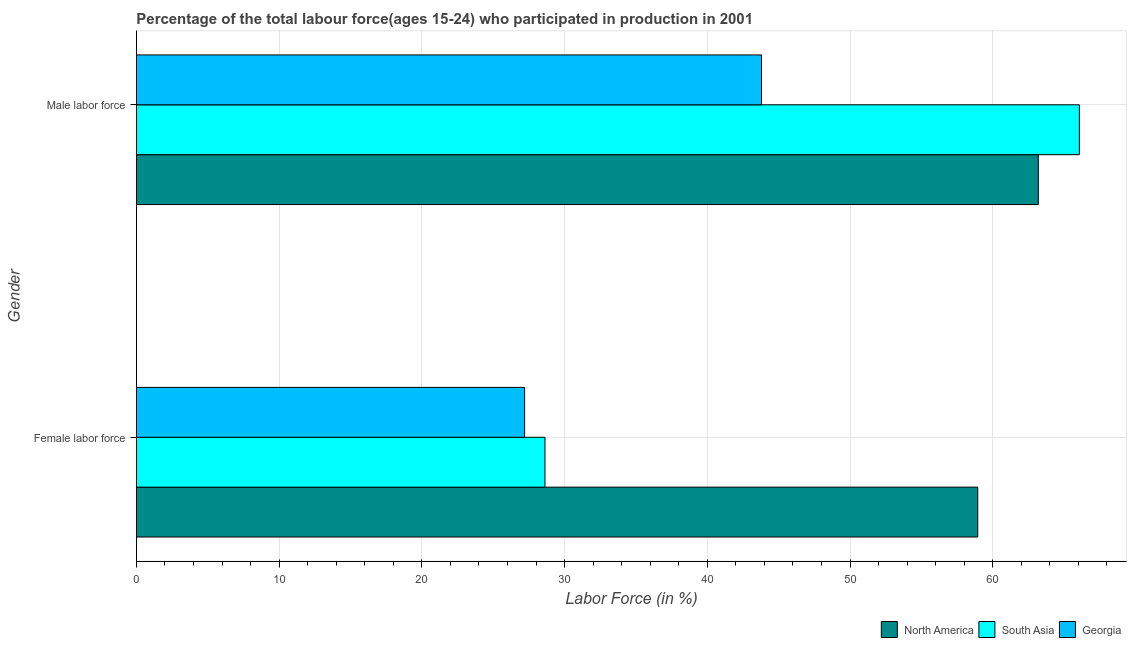How many different coloured bars are there?
Your response must be concise. 3. How many groups of bars are there?
Offer a terse response. 2. How many bars are there on the 2nd tick from the bottom?
Offer a very short reply. 3. What is the label of the 1st group of bars from the top?
Offer a terse response. Male labor force. What is the percentage of male labour force in South Asia?
Offer a terse response. 66.07. Across all countries, what is the maximum percentage of male labour force?
Your answer should be very brief. 66.07. Across all countries, what is the minimum percentage of male labour force?
Your response must be concise. 43.8. In which country was the percentage of female labor force maximum?
Your answer should be compact. North America. In which country was the percentage of male labour force minimum?
Make the answer very short. Georgia. What is the total percentage of female labor force in the graph?
Keep it short and to the point. 114.77. What is the difference between the percentage of male labour force in North America and that in Georgia?
Provide a succinct answer. 19.39. What is the difference between the percentage of male labour force in North America and the percentage of female labor force in Georgia?
Offer a very short reply. 35.99. What is the average percentage of female labor force per country?
Give a very brief answer. 38.26. What is the difference between the percentage of female labor force and percentage of male labour force in South Asia?
Your answer should be compact. -37.44. In how many countries, is the percentage of male labour force greater than 24 %?
Your answer should be compact. 3. What is the ratio of the percentage of male labour force in Georgia to that in South Asia?
Your response must be concise. 0.66. In how many countries, is the percentage of female labor force greater than the average percentage of female labor force taken over all countries?
Give a very brief answer. 1. What does the 1st bar from the top in Male labor force represents?
Provide a short and direct response. Georgia. What does the 2nd bar from the bottom in Male labor force represents?
Provide a succinct answer. South Asia. How many countries are there in the graph?
Your response must be concise. 3. Where does the legend appear in the graph?
Provide a succinct answer. Bottom right. How are the legend labels stacked?
Your answer should be compact. Horizontal. What is the title of the graph?
Your response must be concise. Percentage of the total labour force(ages 15-24) who participated in production in 2001. What is the label or title of the Y-axis?
Make the answer very short. Gender. What is the Labor Force (in %) in North America in Female labor force?
Provide a succinct answer. 58.95. What is the Labor Force (in %) in South Asia in Female labor force?
Keep it short and to the point. 28.63. What is the Labor Force (in %) of Georgia in Female labor force?
Provide a succinct answer. 27.2. What is the Labor Force (in %) in North America in Male labor force?
Provide a short and direct response. 63.19. What is the Labor Force (in %) of South Asia in Male labor force?
Provide a short and direct response. 66.07. What is the Labor Force (in %) in Georgia in Male labor force?
Ensure brevity in your answer.  43.8. Across all Gender, what is the maximum Labor Force (in %) of North America?
Your response must be concise. 63.19. Across all Gender, what is the maximum Labor Force (in %) in South Asia?
Your answer should be compact. 66.07. Across all Gender, what is the maximum Labor Force (in %) of Georgia?
Your answer should be very brief. 43.8. Across all Gender, what is the minimum Labor Force (in %) in North America?
Your answer should be compact. 58.95. Across all Gender, what is the minimum Labor Force (in %) in South Asia?
Ensure brevity in your answer.  28.63. Across all Gender, what is the minimum Labor Force (in %) in Georgia?
Provide a succinct answer. 27.2. What is the total Labor Force (in %) of North America in the graph?
Your answer should be compact. 122.14. What is the total Labor Force (in %) of South Asia in the graph?
Give a very brief answer. 94.69. What is the total Labor Force (in %) of Georgia in the graph?
Your answer should be very brief. 71. What is the difference between the Labor Force (in %) of North America in Female labor force and that in Male labor force?
Provide a short and direct response. -4.25. What is the difference between the Labor Force (in %) in South Asia in Female labor force and that in Male labor force?
Give a very brief answer. -37.44. What is the difference between the Labor Force (in %) of Georgia in Female labor force and that in Male labor force?
Give a very brief answer. -16.6. What is the difference between the Labor Force (in %) of North America in Female labor force and the Labor Force (in %) of South Asia in Male labor force?
Offer a very short reply. -7.12. What is the difference between the Labor Force (in %) of North America in Female labor force and the Labor Force (in %) of Georgia in Male labor force?
Keep it short and to the point. 15.15. What is the difference between the Labor Force (in %) in South Asia in Female labor force and the Labor Force (in %) in Georgia in Male labor force?
Your answer should be very brief. -15.17. What is the average Labor Force (in %) of North America per Gender?
Ensure brevity in your answer.  61.07. What is the average Labor Force (in %) of South Asia per Gender?
Keep it short and to the point. 47.35. What is the average Labor Force (in %) of Georgia per Gender?
Ensure brevity in your answer.  35.5. What is the difference between the Labor Force (in %) of North America and Labor Force (in %) of South Asia in Female labor force?
Your response must be concise. 30.32. What is the difference between the Labor Force (in %) of North America and Labor Force (in %) of Georgia in Female labor force?
Make the answer very short. 31.75. What is the difference between the Labor Force (in %) of South Asia and Labor Force (in %) of Georgia in Female labor force?
Your answer should be very brief. 1.43. What is the difference between the Labor Force (in %) in North America and Labor Force (in %) in South Asia in Male labor force?
Your response must be concise. -2.88. What is the difference between the Labor Force (in %) in North America and Labor Force (in %) in Georgia in Male labor force?
Your response must be concise. 19.39. What is the difference between the Labor Force (in %) of South Asia and Labor Force (in %) of Georgia in Male labor force?
Your answer should be compact. 22.27. What is the ratio of the Labor Force (in %) in North America in Female labor force to that in Male labor force?
Offer a very short reply. 0.93. What is the ratio of the Labor Force (in %) in South Asia in Female labor force to that in Male labor force?
Your answer should be very brief. 0.43. What is the ratio of the Labor Force (in %) in Georgia in Female labor force to that in Male labor force?
Your answer should be compact. 0.62. What is the difference between the highest and the second highest Labor Force (in %) of North America?
Offer a very short reply. 4.25. What is the difference between the highest and the second highest Labor Force (in %) of South Asia?
Provide a short and direct response. 37.44. What is the difference between the highest and the second highest Labor Force (in %) in Georgia?
Your answer should be compact. 16.6. What is the difference between the highest and the lowest Labor Force (in %) of North America?
Keep it short and to the point. 4.25. What is the difference between the highest and the lowest Labor Force (in %) in South Asia?
Offer a very short reply. 37.44. What is the difference between the highest and the lowest Labor Force (in %) of Georgia?
Provide a short and direct response. 16.6. 